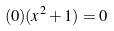<formula> <loc_0><loc_0><loc_500><loc_500>( 0 ) ( x ^ { 2 } + 1 ) = 0</formula> 